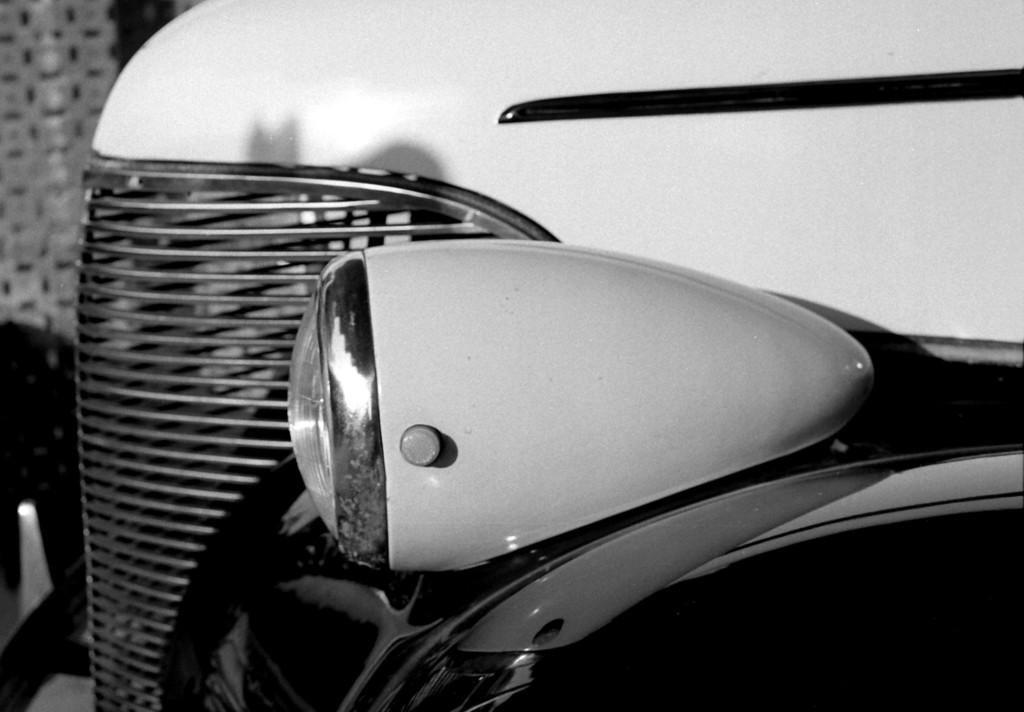What is the main subject of the image? The main subject of the image is a vehicle. Can you describe the style of the image? The image is a black and white photography. Where is the scarecrow located in the image? There is no scarecrow present in the image. How many boys are visible in the image? There are no boys visible in the image. 